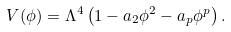<formula> <loc_0><loc_0><loc_500><loc_500>V ( \phi ) = \Lambda ^ { 4 } \left ( 1 - a _ { 2 } \phi ^ { 2 } - a _ { p } \phi ^ { p } \right ) .</formula> 